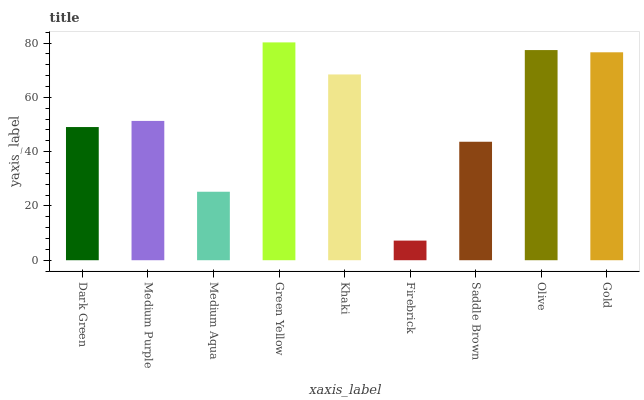Is Firebrick the minimum?
Answer yes or no. Yes. Is Green Yellow the maximum?
Answer yes or no. Yes. Is Medium Purple the minimum?
Answer yes or no. No. Is Medium Purple the maximum?
Answer yes or no. No. Is Medium Purple greater than Dark Green?
Answer yes or no. Yes. Is Dark Green less than Medium Purple?
Answer yes or no. Yes. Is Dark Green greater than Medium Purple?
Answer yes or no. No. Is Medium Purple less than Dark Green?
Answer yes or no. No. Is Medium Purple the high median?
Answer yes or no. Yes. Is Medium Purple the low median?
Answer yes or no. Yes. Is Medium Aqua the high median?
Answer yes or no. No. Is Firebrick the low median?
Answer yes or no. No. 